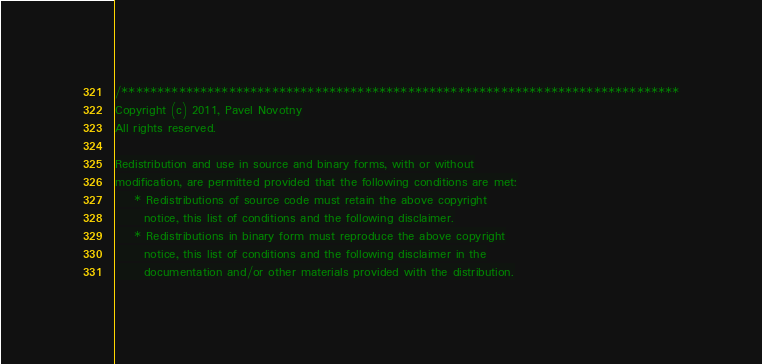<code> <loc_0><loc_0><loc_500><loc_500><_C_>/******************************************************************************
Copyright (c) 2011, Pavel Novotny
All rights reserved.

Redistribution and use in source and binary forms, with or without
modification, are permitted provided that the following conditions are met:
    * Redistributions of source code must retain the above copyright
      notice, this list of conditions and the following disclaimer.
    * Redistributions in binary form must reproduce the above copyright
      notice, this list of conditions and the following disclaimer in the
      documentation and/or other materials provided with the distribution.</code> 